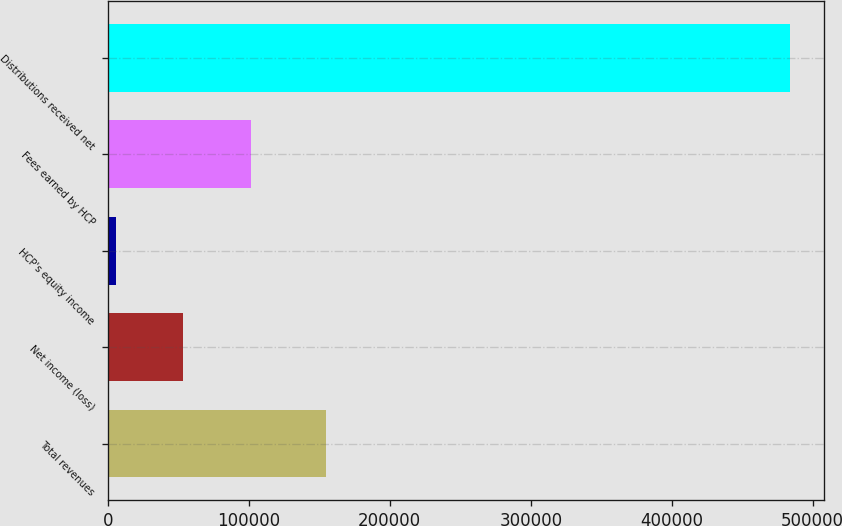Convert chart to OTSL. <chart><loc_0><loc_0><loc_500><loc_500><bar_chart><fcel>Total revenues<fcel>Net income (loss)<fcel>HCP's equity income<fcel>Fees earned by HCP<fcel>Distributions received net<nl><fcel>154748<fcel>53436.2<fcel>5645<fcel>101227<fcel>483557<nl></chart> 